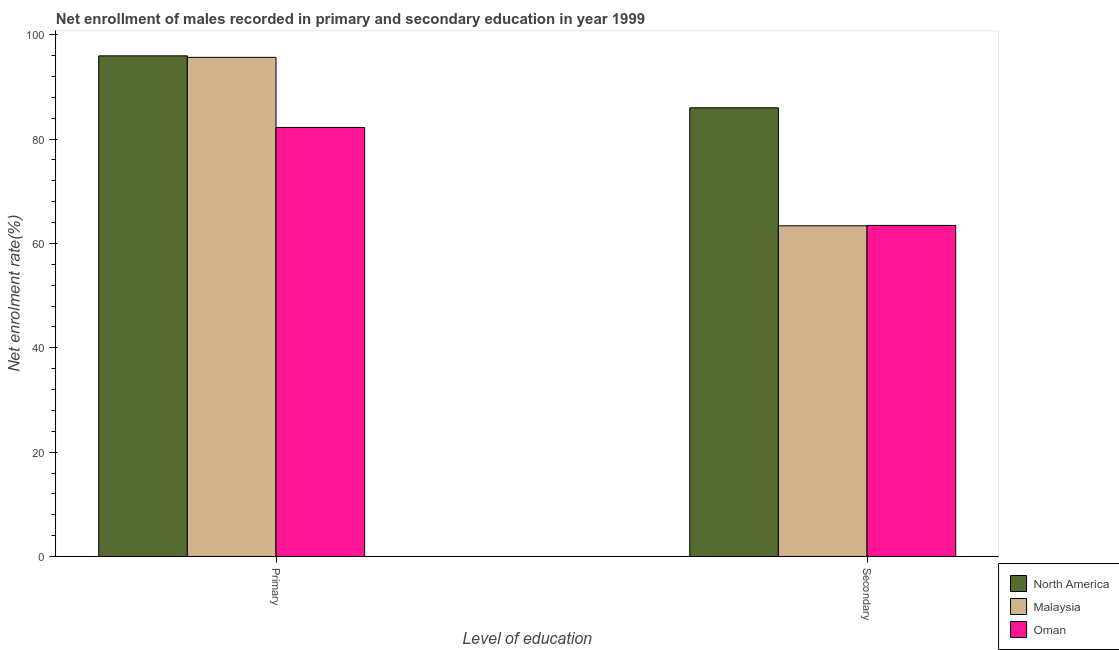How many different coloured bars are there?
Keep it short and to the point. 3. How many groups of bars are there?
Provide a succinct answer. 2. What is the label of the 1st group of bars from the left?
Your answer should be very brief. Primary. What is the enrollment rate in primary education in Oman?
Ensure brevity in your answer.  82.22. Across all countries, what is the maximum enrollment rate in primary education?
Make the answer very short. 95.94. Across all countries, what is the minimum enrollment rate in secondary education?
Offer a terse response. 63.38. In which country was the enrollment rate in primary education maximum?
Your response must be concise. North America. In which country was the enrollment rate in primary education minimum?
Make the answer very short. Oman. What is the total enrollment rate in secondary education in the graph?
Ensure brevity in your answer.  212.81. What is the difference between the enrollment rate in secondary education in North America and that in Oman?
Provide a succinct answer. 22.54. What is the difference between the enrollment rate in secondary education in Malaysia and the enrollment rate in primary education in North America?
Ensure brevity in your answer.  -32.57. What is the average enrollment rate in primary education per country?
Make the answer very short. 91.27. What is the difference between the enrollment rate in primary education and enrollment rate in secondary education in Oman?
Your response must be concise. 18.77. What is the ratio of the enrollment rate in primary education in North America to that in Oman?
Ensure brevity in your answer.  1.17. In how many countries, is the enrollment rate in primary education greater than the average enrollment rate in primary education taken over all countries?
Make the answer very short. 2. What does the 1st bar from the left in Secondary represents?
Make the answer very short. North America. What does the 3rd bar from the right in Primary represents?
Offer a terse response. North America. How many bars are there?
Keep it short and to the point. 6. How many countries are there in the graph?
Provide a short and direct response. 3. Does the graph contain any zero values?
Your answer should be very brief. No. Does the graph contain grids?
Provide a short and direct response. No. Where does the legend appear in the graph?
Make the answer very short. Bottom right. What is the title of the graph?
Your answer should be very brief. Net enrollment of males recorded in primary and secondary education in year 1999. Does "Ethiopia" appear as one of the legend labels in the graph?
Offer a terse response. No. What is the label or title of the X-axis?
Ensure brevity in your answer.  Level of education. What is the label or title of the Y-axis?
Offer a terse response. Net enrolment rate(%). What is the Net enrolment rate(%) of North America in Primary?
Make the answer very short. 95.94. What is the Net enrolment rate(%) in Malaysia in Primary?
Ensure brevity in your answer.  95.65. What is the Net enrolment rate(%) of Oman in Primary?
Offer a very short reply. 82.22. What is the Net enrolment rate(%) in North America in Secondary?
Offer a terse response. 85.99. What is the Net enrolment rate(%) of Malaysia in Secondary?
Your response must be concise. 63.38. What is the Net enrolment rate(%) in Oman in Secondary?
Provide a succinct answer. 63.45. Across all Level of education, what is the maximum Net enrolment rate(%) of North America?
Offer a very short reply. 95.94. Across all Level of education, what is the maximum Net enrolment rate(%) of Malaysia?
Your response must be concise. 95.65. Across all Level of education, what is the maximum Net enrolment rate(%) of Oman?
Offer a very short reply. 82.22. Across all Level of education, what is the minimum Net enrolment rate(%) in North America?
Give a very brief answer. 85.99. Across all Level of education, what is the minimum Net enrolment rate(%) of Malaysia?
Your answer should be very brief. 63.38. Across all Level of education, what is the minimum Net enrolment rate(%) in Oman?
Offer a terse response. 63.45. What is the total Net enrolment rate(%) of North America in the graph?
Your response must be concise. 181.93. What is the total Net enrolment rate(%) of Malaysia in the graph?
Keep it short and to the point. 159.03. What is the total Net enrolment rate(%) in Oman in the graph?
Offer a terse response. 145.68. What is the difference between the Net enrolment rate(%) in North America in Primary and that in Secondary?
Your response must be concise. 9.96. What is the difference between the Net enrolment rate(%) in Malaysia in Primary and that in Secondary?
Give a very brief answer. 32.28. What is the difference between the Net enrolment rate(%) in Oman in Primary and that in Secondary?
Keep it short and to the point. 18.77. What is the difference between the Net enrolment rate(%) of North America in Primary and the Net enrolment rate(%) of Malaysia in Secondary?
Give a very brief answer. 32.57. What is the difference between the Net enrolment rate(%) in North America in Primary and the Net enrolment rate(%) in Oman in Secondary?
Your answer should be very brief. 32.49. What is the difference between the Net enrolment rate(%) of Malaysia in Primary and the Net enrolment rate(%) of Oman in Secondary?
Offer a terse response. 32.2. What is the average Net enrolment rate(%) in North America per Level of education?
Your answer should be very brief. 90.96. What is the average Net enrolment rate(%) in Malaysia per Level of education?
Give a very brief answer. 79.52. What is the average Net enrolment rate(%) in Oman per Level of education?
Your answer should be compact. 72.84. What is the difference between the Net enrolment rate(%) in North America and Net enrolment rate(%) in Malaysia in Primary?
Provide a succinct answer. 0.29. What is the difference between the Net enrolment rate(%) of North America and Net enrolment rate(%) of Oman in Primary?
Provide a short and direct response. 13.72. What is the difference between the Net enrolment rate(%) in Malaysia and Net enrolment rate(%) in Oman in Primary?
Give a very brief answer. 13.43. What is the difference between the Net enrolment rate(%) in North America and Net enrolment rate(%) in Malaysia in Secondary?
Ensure brevity in your answer.  22.61. What is the difference between the Net enrolment rate(%) in North America and Net enrolment rate(%) in Oman in Secondary?
Offer a terse response. 22.54. What is the difference between the Net enrolment rate(%) in Malaysia and Net enrolment rate(%) in Oman in Secondary?
Ensure brevity in your answer.  -0.08. What is the ratio of the Net enrolment rate(%) of North America in Primary to that in Secondary?
Ensure brevity in your answer.  1.12. What is the ratio of the Net enrolment rate(%) of Malaysia in Primary to that in Secondary?
Give a very brief answer. 1.51. What is the ratio of the Net enrolment rate(%) in Oman in Primary to that in Secondary?
Provide a succinct answer. 1.3. What is the difference between the highest and the second highest Net enrolment rate(%) of North America?
Your answer should be very brief. 9.96. What is the difference between the highest and the second highest Net enrolment rate(%) of Malaysia?
Your answer should be very brief. 32.28. What is the difference between the highest and the second highest Net enrolment rate(%) of Oman?
Give a very brief answer. 18.77. What is the difference between the highest and the lowest Net enrolment rate(%) of North America?
Provide a short and direct response. 9.96. What is the difference between the highest and the lowest Net enrolment rate(%) of Malaysia?
Provide a short and direct response. 32.28. What is the difference between the highest and the lowest Net enrolment rate(%) of Oman?
Provide a succinct answer. 18.77. 